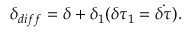Convert formula to latex. <formula><loc_0><loc_0><loc_500><loc_500>\delta _ { d i f f } = \delta + \delta _ { 1 } ( \delta \tau _ { 1 } = \dot { \delta \tau } ) .</formula> 